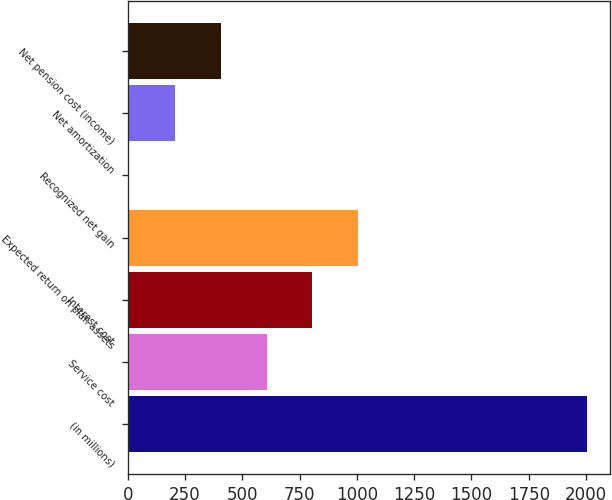Convert chart to OTSL. <chart><loc_0><loc_0><loc_500><loc_500><bar_chart><fcel>(in millions)<fcel>Service cost<fcel>Interest cost<fcel>Expected return on plan assets<fcel>Recognized net gain<fcel>Net amortization<fcel>Net pension cost (income)<nl><fcel>2004<fcel>606.1<fcel>805.8<fcel>1005.5<fcel>7<fcel>206.7<fcel>406.4<nl></chart> 